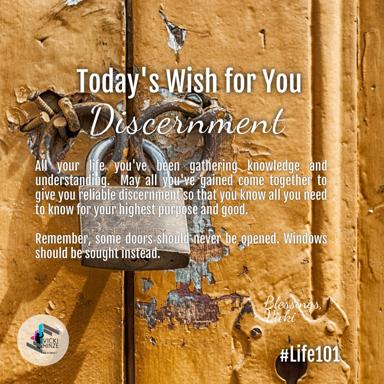How does the visual design of this image contribute to its message about discernment? The rustic door with its chipped paint and antique lock is symbolic, suggesting that some old or traditional choices (doors) might need reevaluation or avoidance for better alternatives (windows). The weathered texture and robust character of the door could also signify the texture of life experiences that lead to true discernment. 